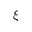<formula> <loc_0><loc_0><loc_500><loc_500>\xi</formula> 